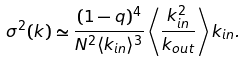<formula> <loc_0><loc_0><loc_500><loc_500>\sigma ^ { 2 } ( { k } ) \simeq \frac { ( 1 - q ) ^ { 4 } } { N ^ { 2 } \langle k _ { i n } \rangle ^ { 3 } } \left \langle \frac { k _ { i n } ^ { 2 } } { k _ { o u t } } \right \rangle k _ { i n } .</formula> 